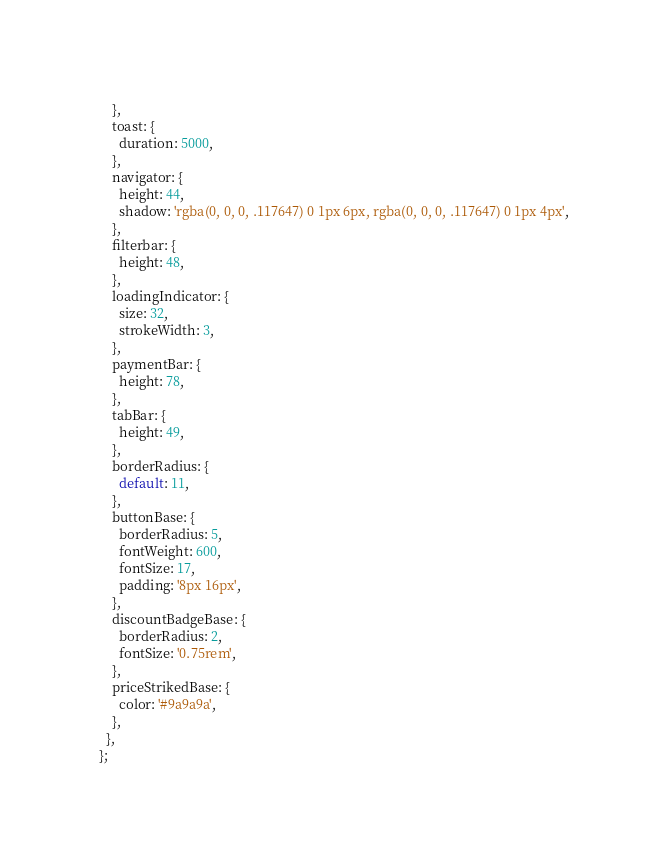<code> <loc_0><loc_0><loc_500><loc_500><_JavaScript_>    },
    toast: {
      duration: 5000,
    },
    navigator: {
      height: 44,
      shadow: 'rgba(0, 0, 0, .117647) 0 1px 6px, rgba(0, 0, 0, .117647) 0 1px 4px',
    },
    filterbar: {
      height: 48,
    },
    loadingIndicator: {
      size: 32,
      strokeWidth: 3,
    },
    paymentBar: {
      height: 78,
    },
    tabBar: {
      height: 49,
    },
    borderRadius: {
      default: 11,
    },
    buttonBase: {
      borderRadius: 5,
      fontWeight: 600,
      fontSize: 17,
      padding: '8px 16px',
    },
    discountBadgeBase: {
      borderRadius: 2,
      fontSize: '0.75rem',
    },
    priceStrikedBase: {
      color: '#9a9a9a',
    },
  },
};
</code> 